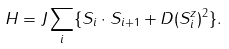Convert formula to latex. <formula><loc_0><loc_0><loc_500><loc_500>H = J \sum _ { i } \{ { S } _ { i } \cdot { S } _ { i + 1 } + D ( S _ { i } ^ { z } ) ^ { 2 } \} .</formula> 